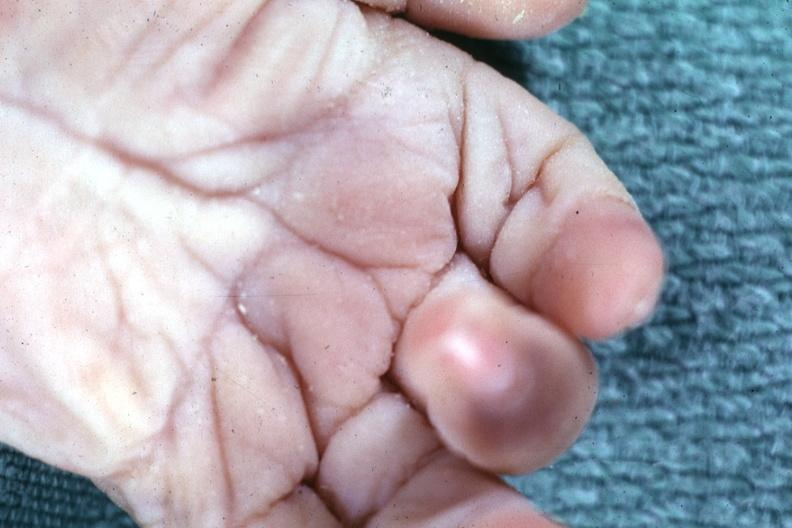re extremities present?
Answer the question using a single word or phrase. Yes 